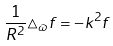Convert formula to latex. <formula><loc_0><loc_0><loc_500><loc_500>\frac { 1 } { R ^ { 2 } } \triangle _ { \varpi } f = - k ^ { 2 } f</formula> 